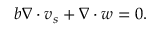<formula> <loc_0><loc_0><loc_500><loc_500>b \nabla \cdot v _ { s } + \nabla \cdot w = 0 .</formula> 